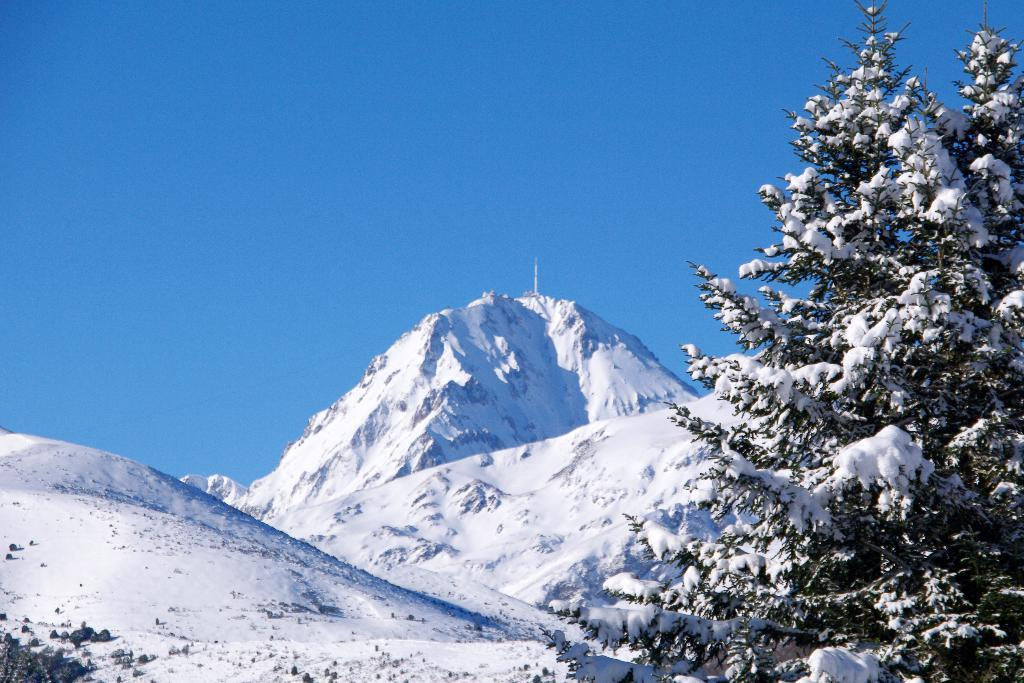What type of natural landform can be seen in the image? There are mountains in the image. What type of vegetation is present in the image? There are trees in the image. What is the weather like in the image? There is snow in the image, suggesting a cold or snowy environment. What color is the sky in the image? The sky is blue in the image. Can you see any planes flying over the mountains in the image? There are no planes visible in the image. Is there any toothpaste present in the image? There is no toothpaste present in the image. Is anyone wearing a hat in the image? There is no hat visible in the image. 